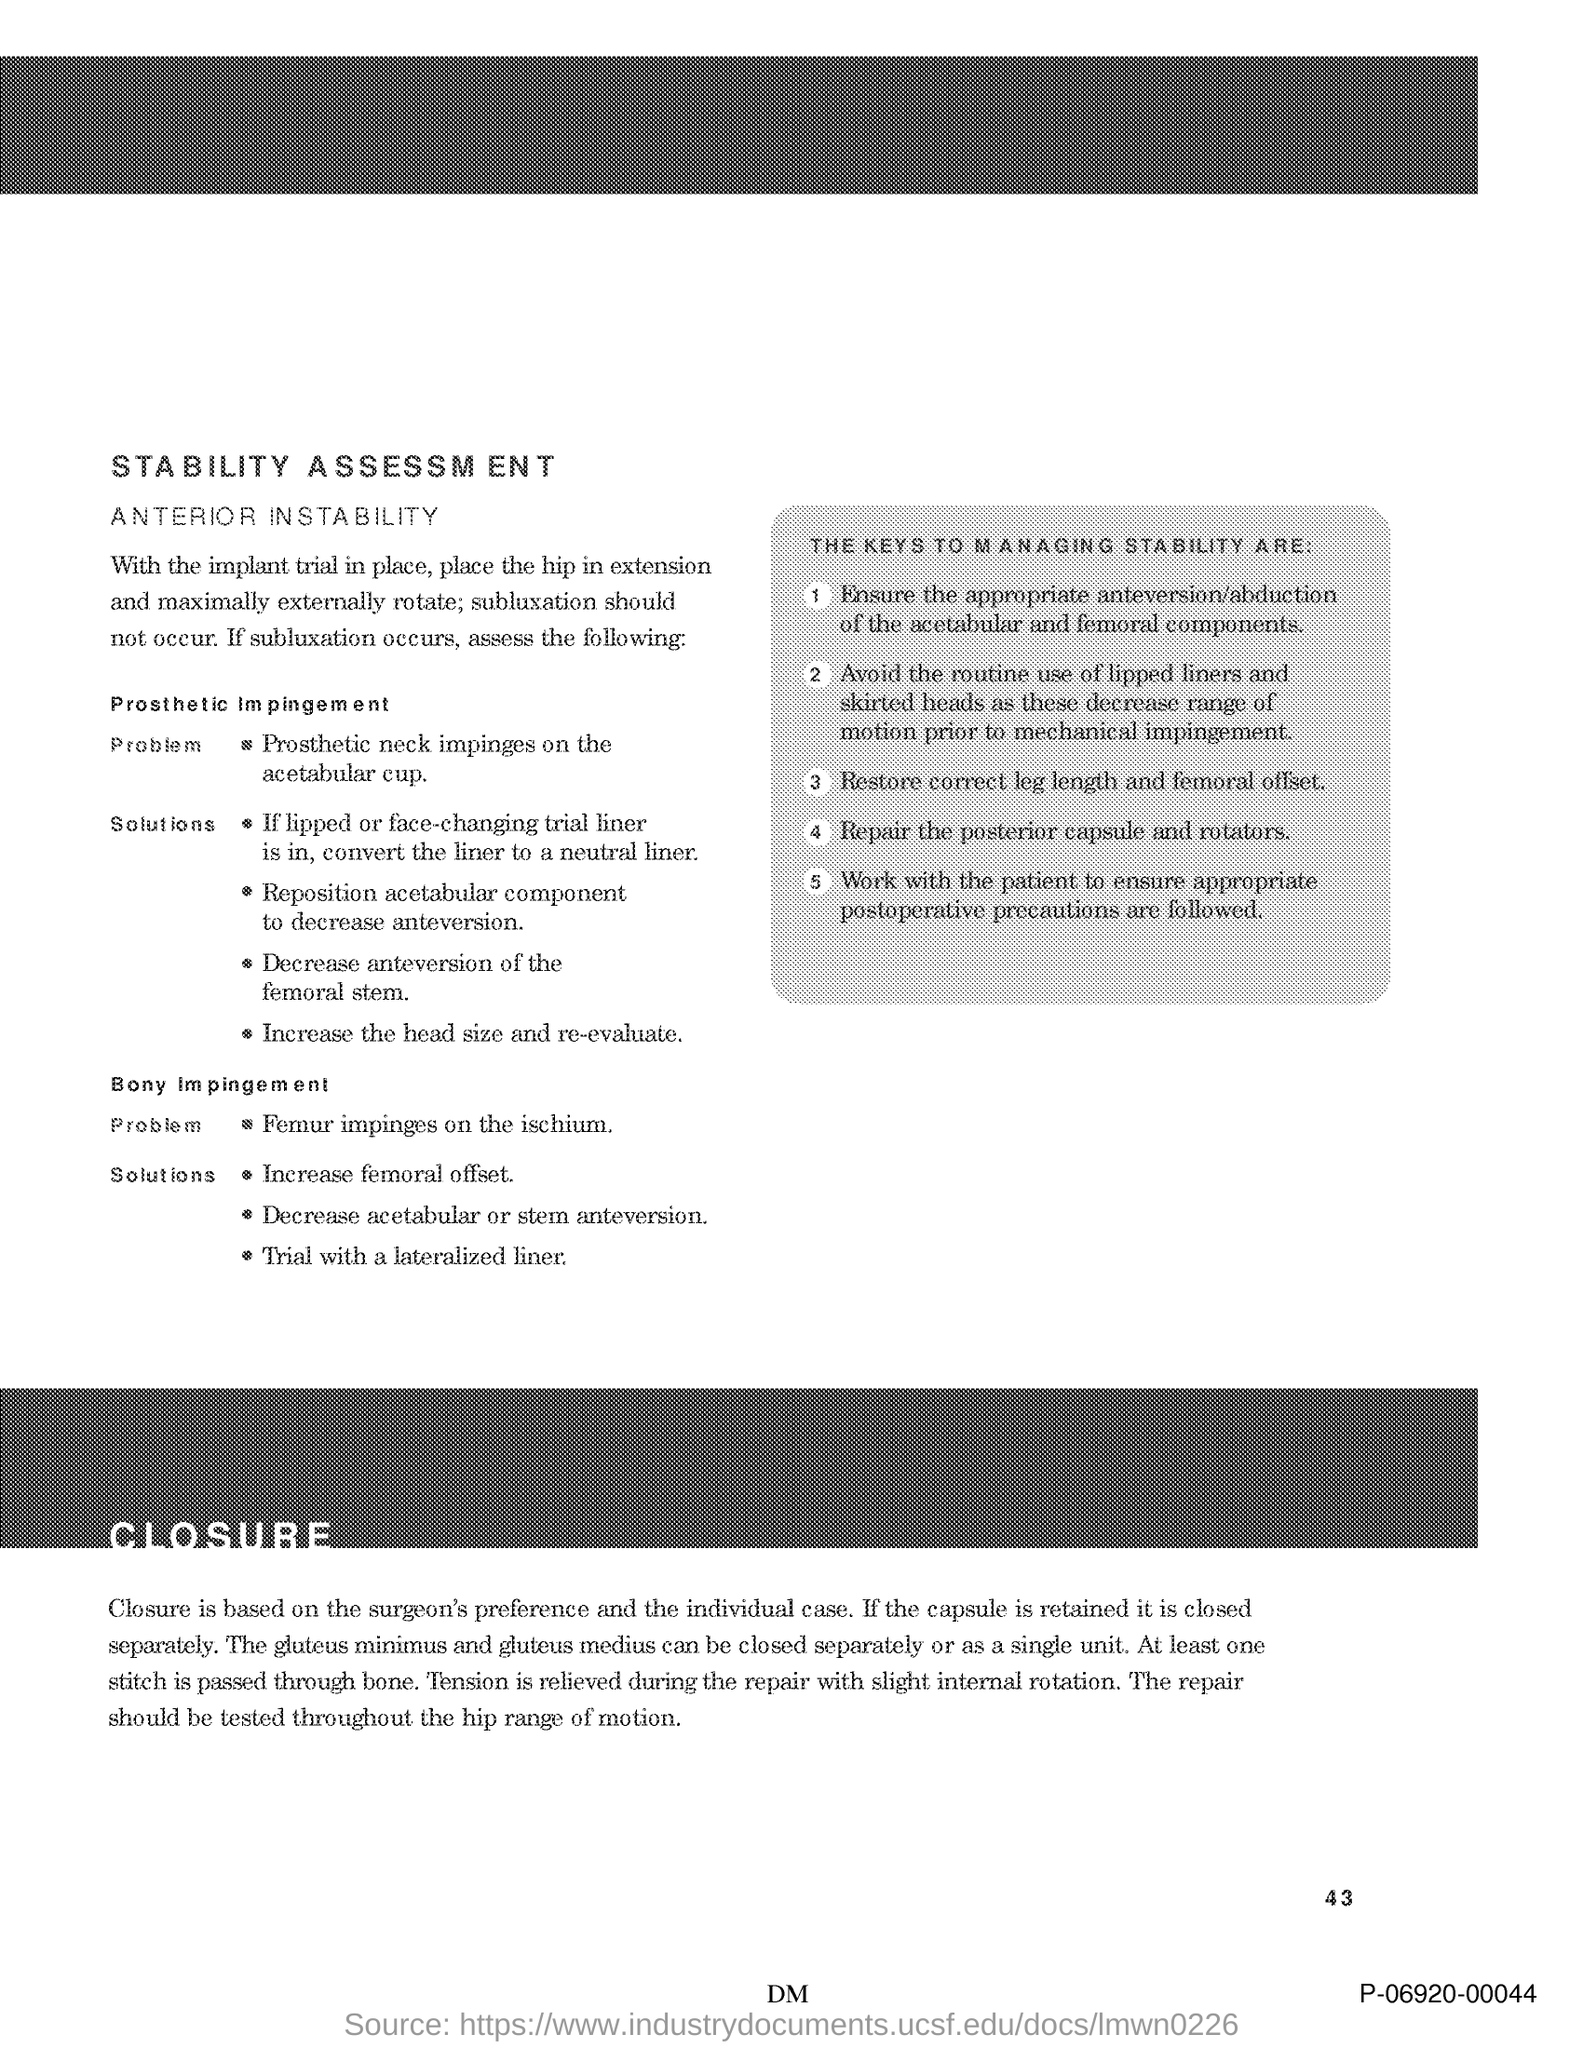List a handful of essential elements in this visual. The number at the bottom right side of the page is 43. 